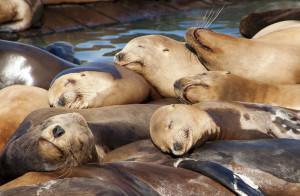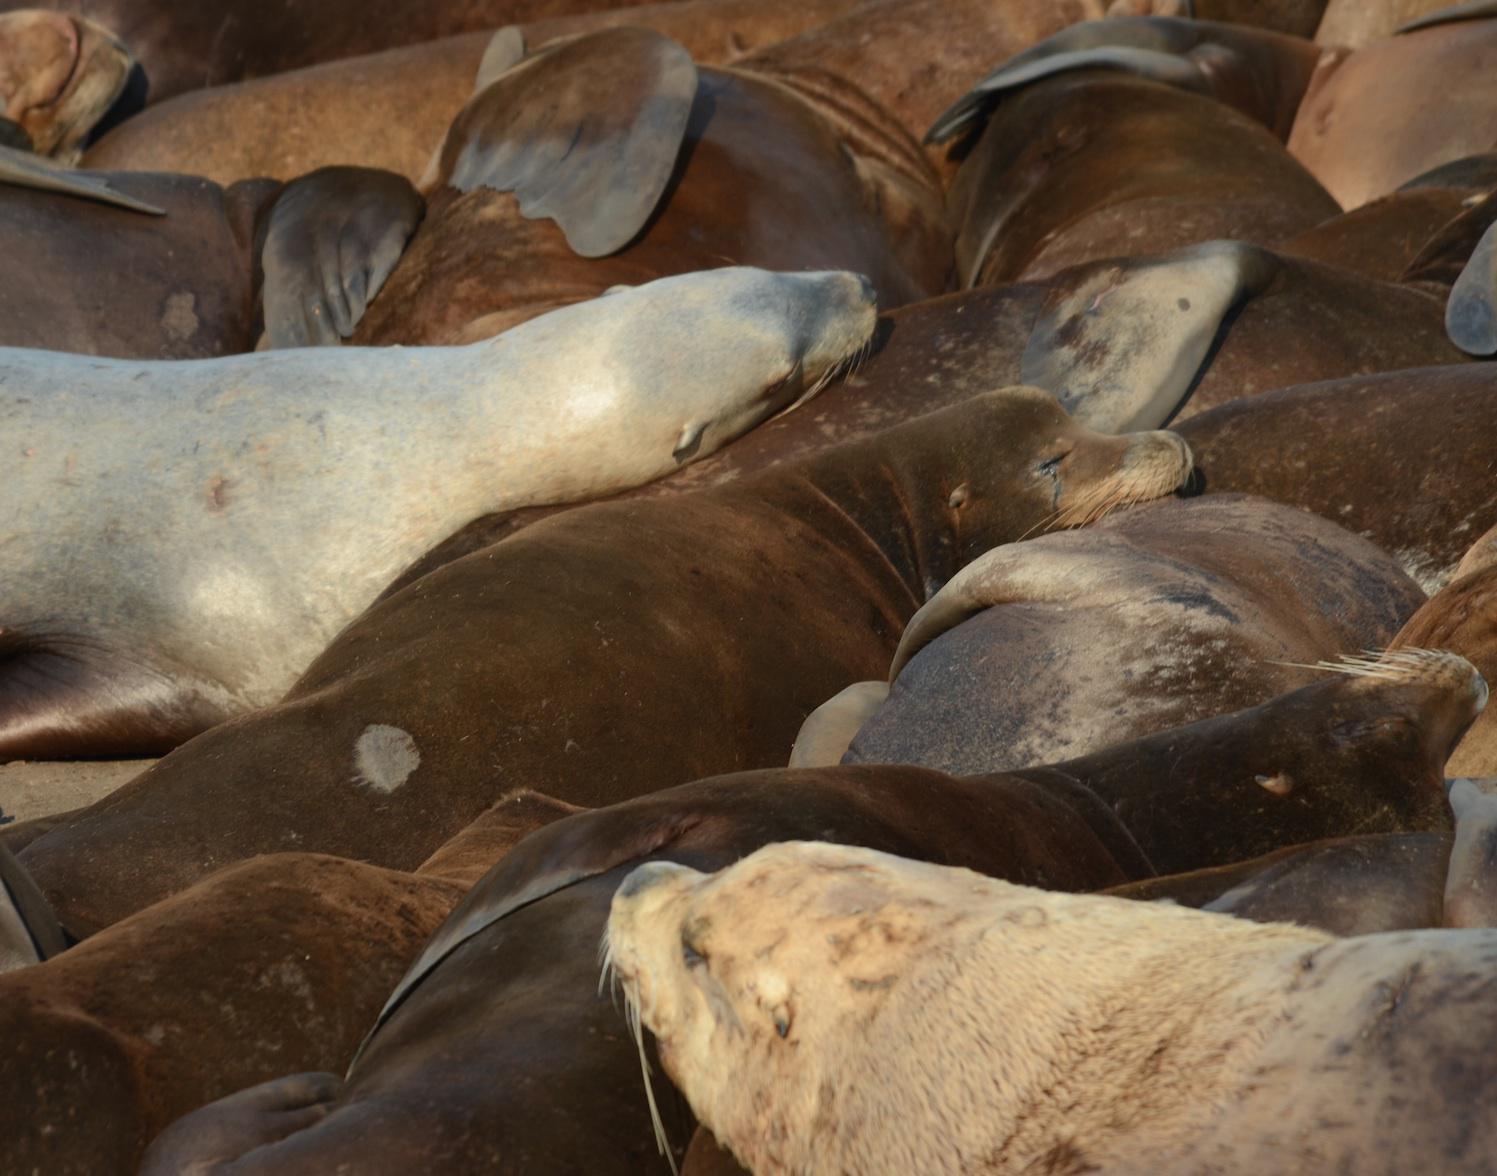The first image is the image on the left, the second image is the image on the right. Evaluate the accuracy of this statement regarding the images: "One image shows no more than three seals in the foreground, and the other shows seals piled on top of each other.". Is it true? Answer yes or no. No. The first image is the image on the left, the second image is the image on the right. Examine the images to the left and right. Is the description "The left hand image shows less than four seals laying on the ground." accurate? Answer yes or no. No. 